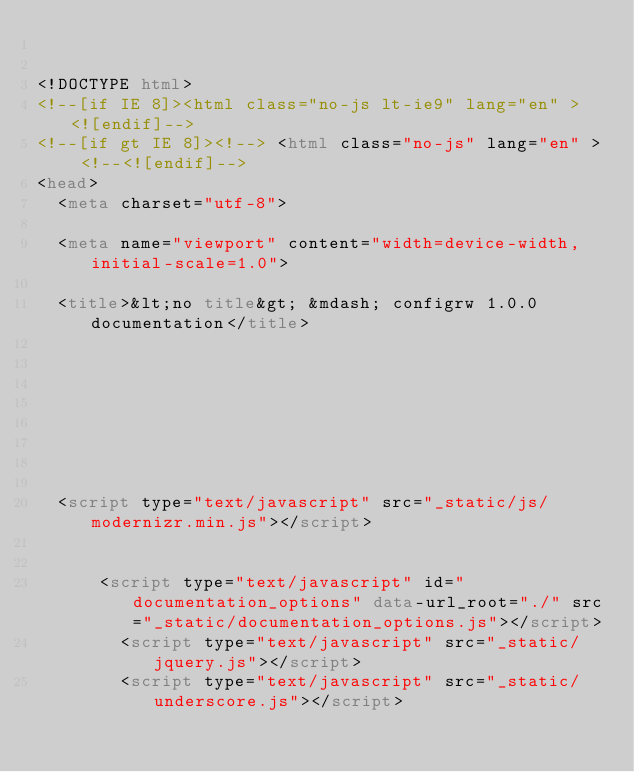<code> <loc_0><loc_0><loc_500><loc_500><_HTML_>

<!DOCTYPE html>
<!--[if IE 8]><html class="no-js lt-ie9" lang="en" > <![endif]-->
<!--[if gt IE 8]><!--> <html class="no-js" lang="en" > <!--<![endif]-->
<head>
  <meta charset="utf-8">
  
  <meta name="viewport" content="width=device-width, initial-scale=1.0">
  
  <title>&lt;no title&gt; &mdash; configrw 1.0.0 documentation</title>
  

  
  
  
  

  
  <script type="text/javascript" src="_static/js/modernizr.min.js"></script>
  
    
      <script type="text/javascript" id="documentation_options" data-url_root="./" src="_static/documentation_options.js"></script>
        <script type="text/javascript" src="_static/jquery.js"></script>
        <script type="text/javascript" src="_static/underscore.js"></script></code> 